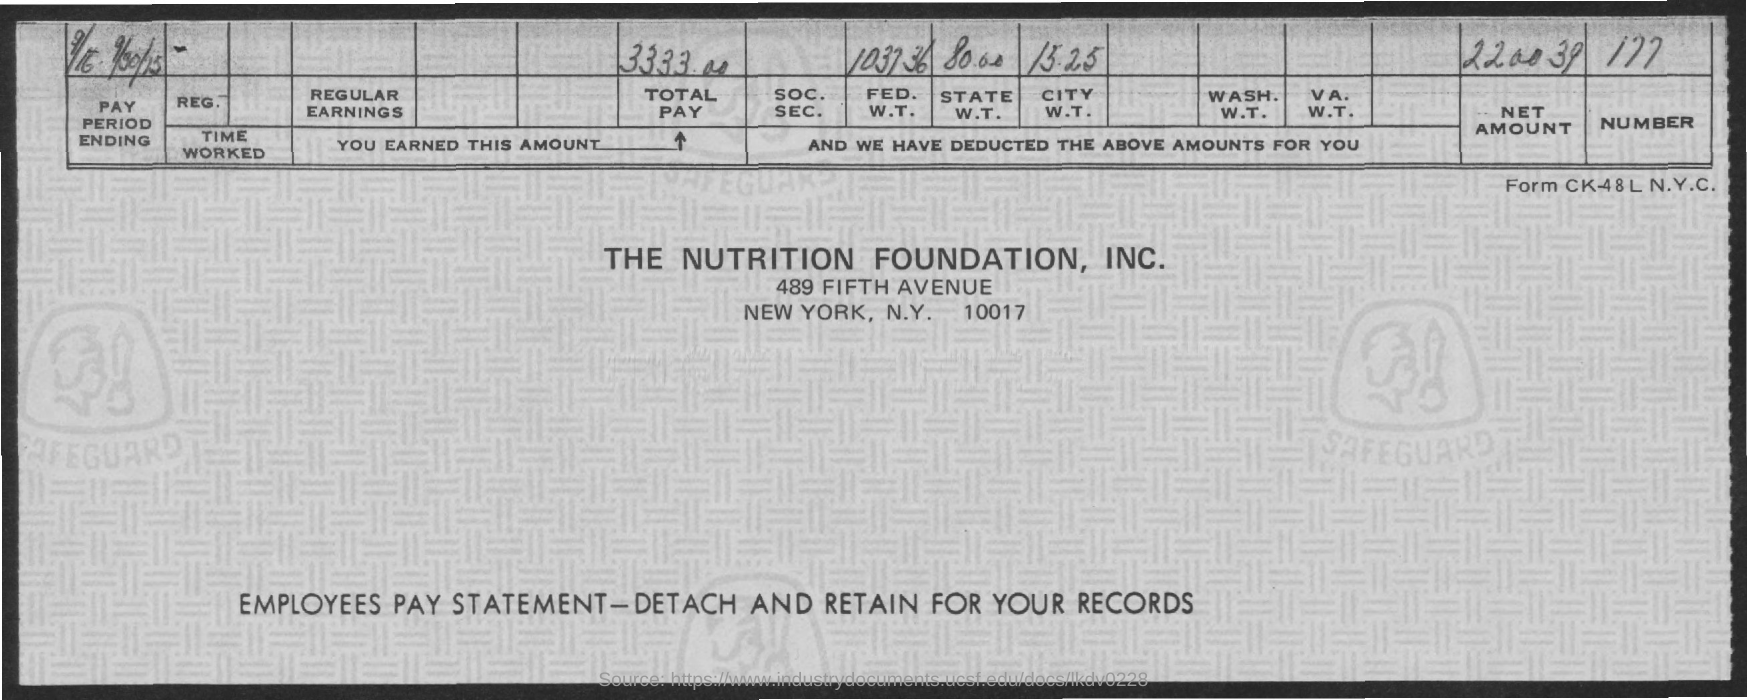What is this form about?
Your answer should be very brief. Employees pay statement. How much is the total pay?
Keep it short and to the point. 3333.00. What  is the net amount specified?
Keep it short and to the point. 220039. 